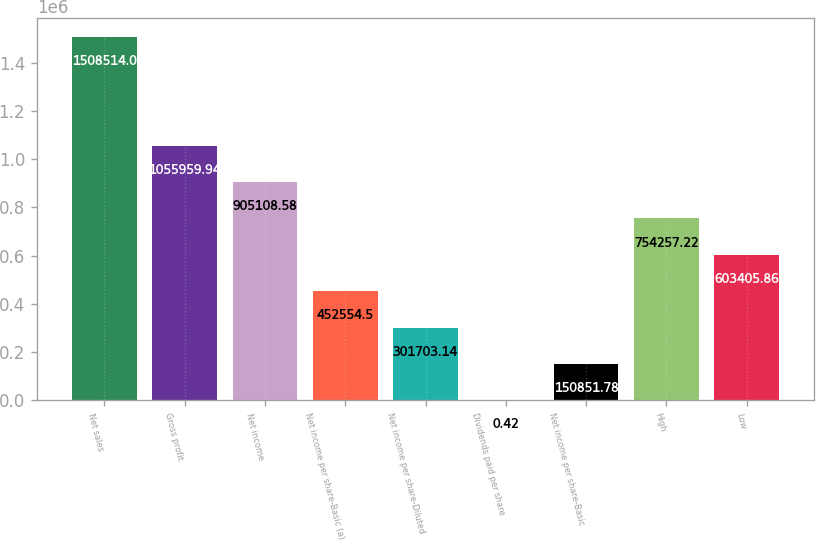Convert chart. <chart><loc_0><loc_0><loc_500><loc_500><bar_chart><fcel>Net sales<fcel>Gross profit<fcel>Net income<fcel>Net income per share-Basic (a)<fcel>Net income per share-Diluted<fcel>Dividends paid per share<fcel>Net income per share-Basic<fcel>High<fcel>Low<nl><fcel>1.50851e+06<fcel>1.05596e+06<fcel>905109<fcel>452554<fcel>301703<fcel>0.42<fcel>150852<fcel>754257<fcel>603406<nl></chart> 